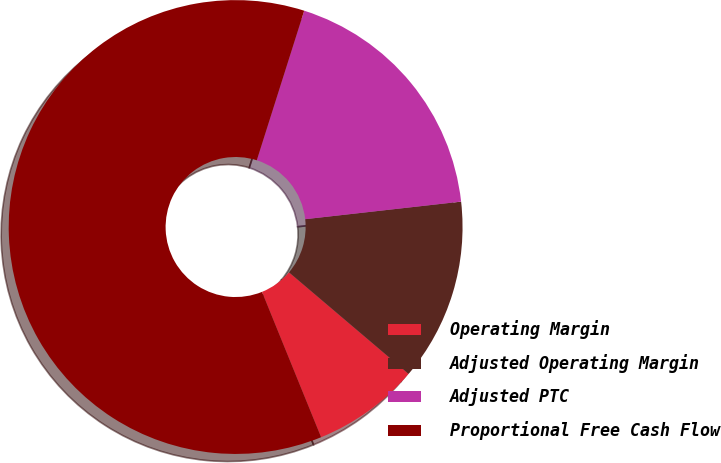Convert chart. <chart><loc_0><loc_0><loc_500><loc_500><pie_chart><fcel>Operating Margin<fcel>Adjusted Operating Margin<fcel>Adjusted PTC<fcel>Proportional Free Cash Flow<nl><fcel>7.65%<fcel>12.99%<fcel>18.33%<fcel>61.04%<nl></chart> 